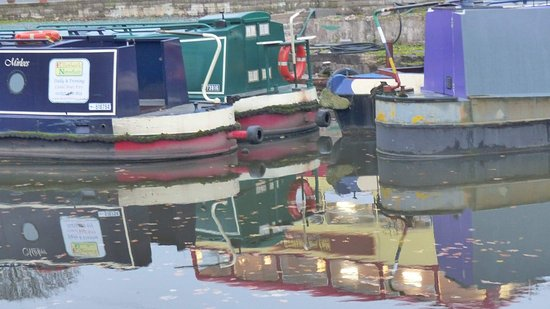What colors are the boats in the image? The boats display a charming variety of colors. The foremost one has blue with white trim, the middle boat is primarily green, and the one furthest from view is predominantly red with some green as well. 